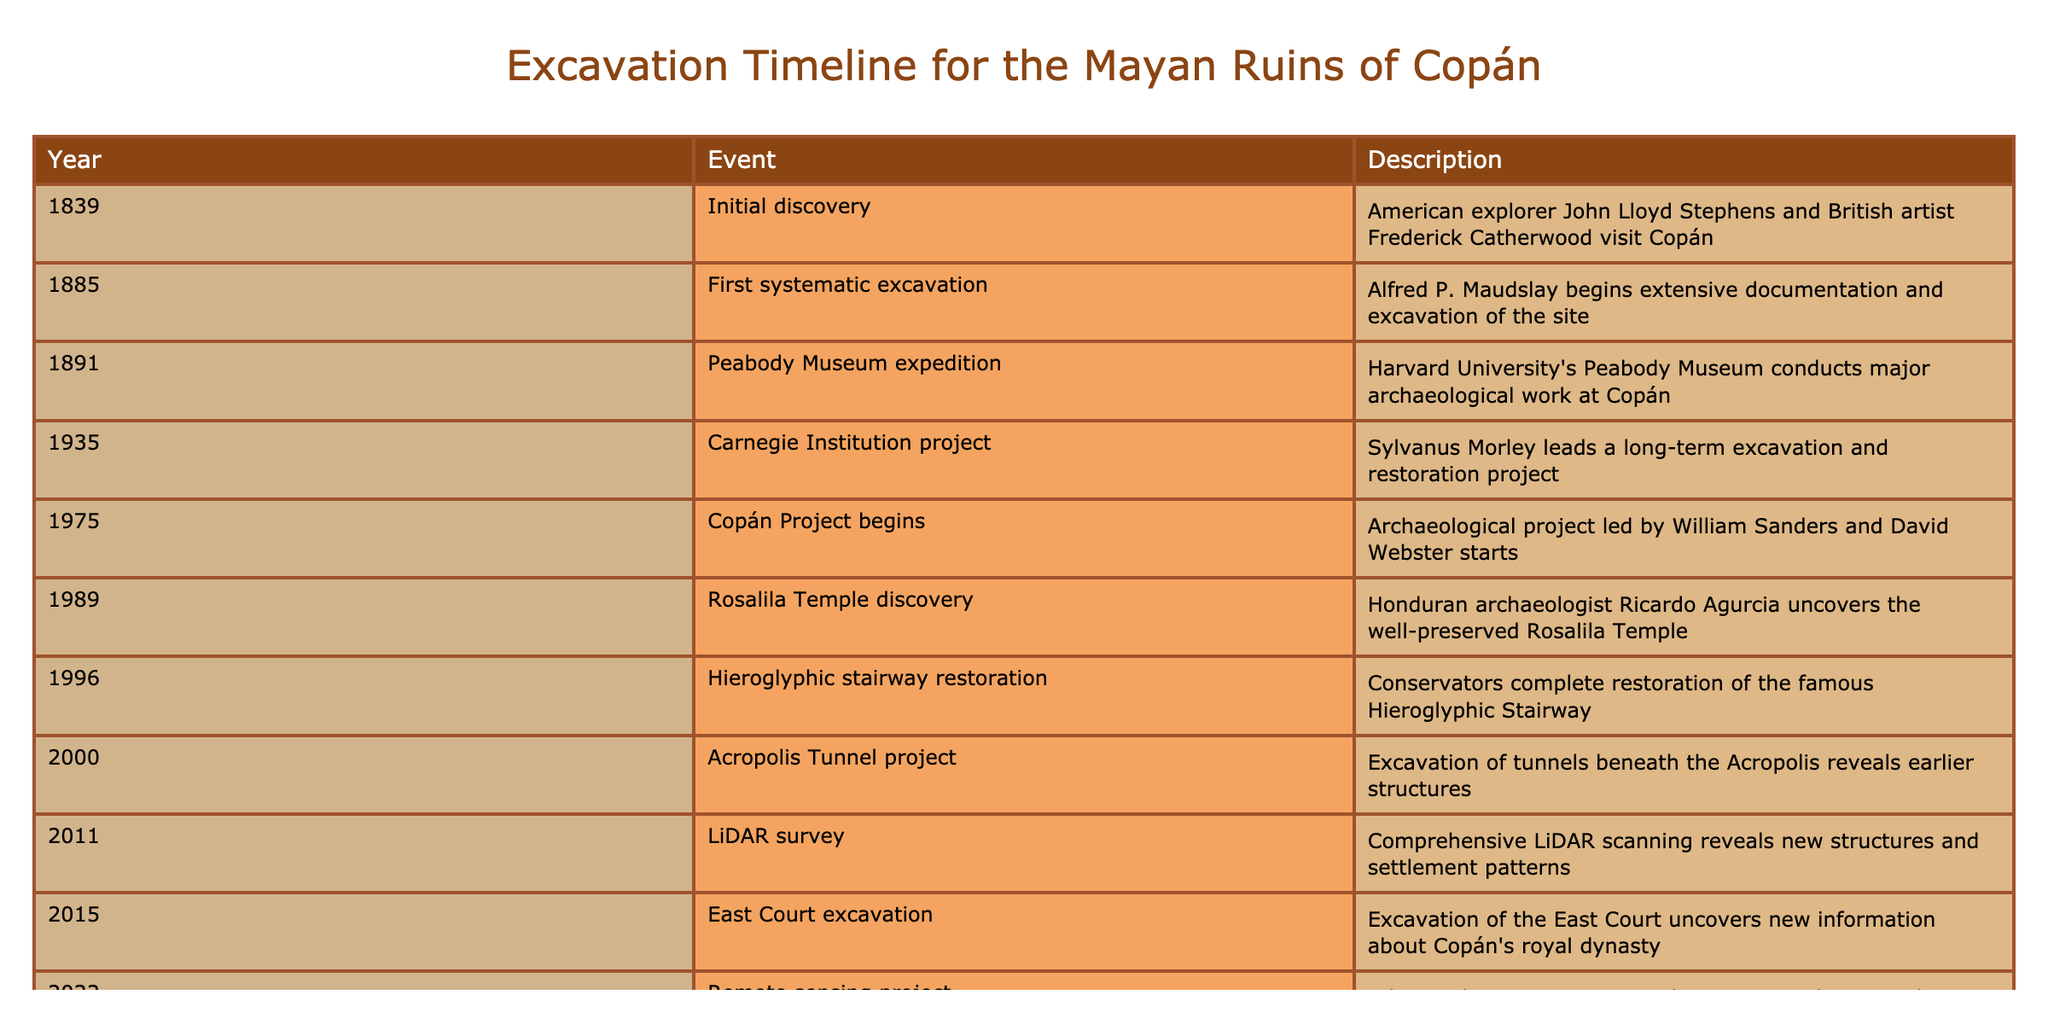What year did the first systematic excavation begin at Copán? The table shows that the first systematic excavation at Copán began in the year 1885.
Answer: 1885 Who led the long-term excavation and restoration project in 1935? According to the table, the long-term excavation and restoration project in 1935 was led by Sylvanus Morley.
Answer: Sylvanus Morley Is it true that the Rosalila Temple was discovered before the Copán Project began? The table indicates that the Rosalila Temple was discovered in 1989, and the Copán Project began in 1975, which means that the temple was discovered after the project started. Therefore, the statement is false.
Answer: No How many years were there between the initial discovery and the first systematic excavation of Copán? The initial discovery was in 1839 and the first systematic excavation began in 1885. The difference between 1885 and 1839 is 46 years.
Answer: 46 years Which event occurred directly after the Peabody Museum expedition in 1891? The table indicates that the event that occurred immediately after the Peabody Museum expedition in 1891 was the Carnegie Institution project starting in 1935.
Answer: Carnegie Institution project What is the average year for the events listed in the timeline? To find the average year, sum all the years: (1839 + 1885 + 1891 + 1935 + 1975 + 1989 + 1996 + 2000 + 2011 + 2015 + 2022) = 20942, then divide by the number of events (11), which gives us an average year of 1904.
Answer: 1904 Was there an archaeological project focused on Copán during the year 2000? The table presents the Acropolis Tunnel project, which occurred in the year 2000, confirming that there was indeed an archaeological project that year.
Answer: Yes Which event had the earliest date in the timeline? The table displays that the earliest event in the timeline is the initial discovery in 1839.
Answer: Initial discovery in 1839 In what year was the LiDAR survey conducted, and what did it reveal? The LiDAR survey was conducted in 2011 and it revealed new structures and settlement patterns at Copán.
Answer: 2011, revealed new structures and settlement patterns 